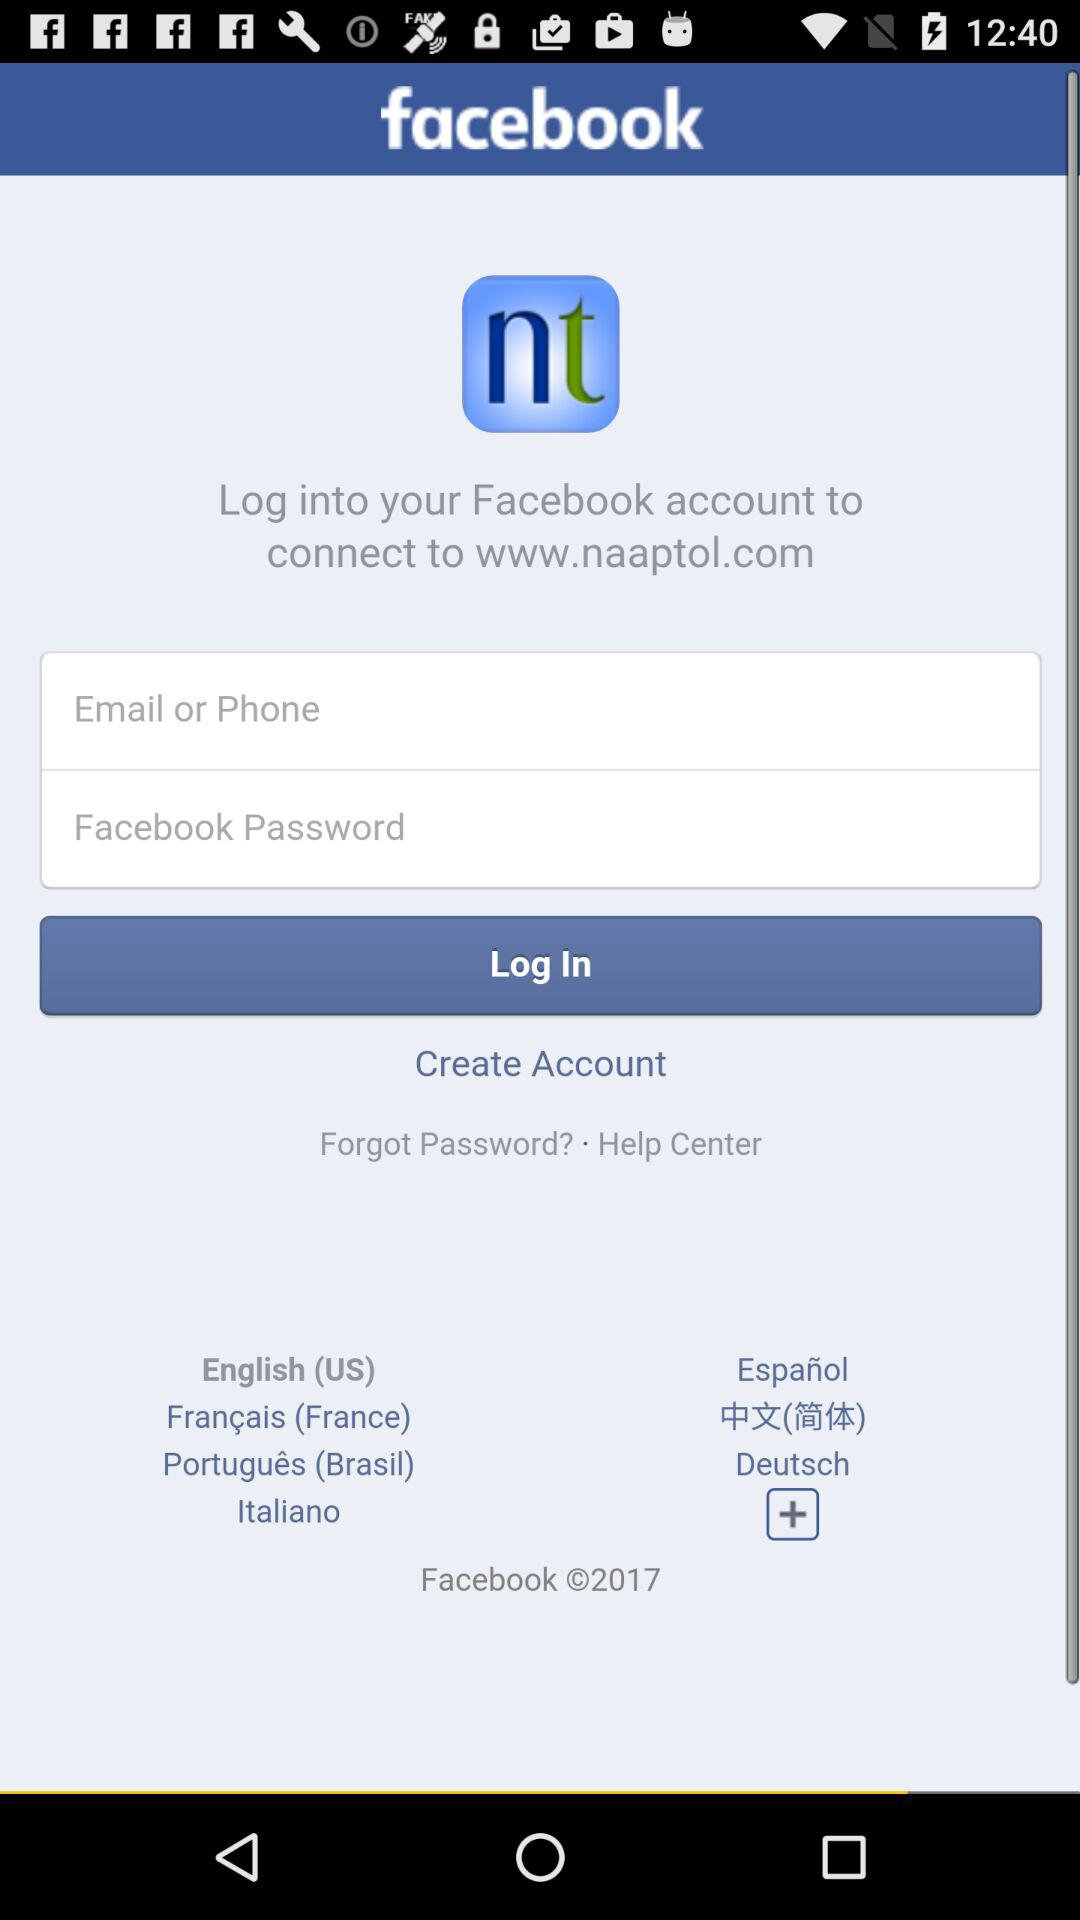What is the name of the website where the user has to connect? The website where the user has to connect is www.naaptol.com. 